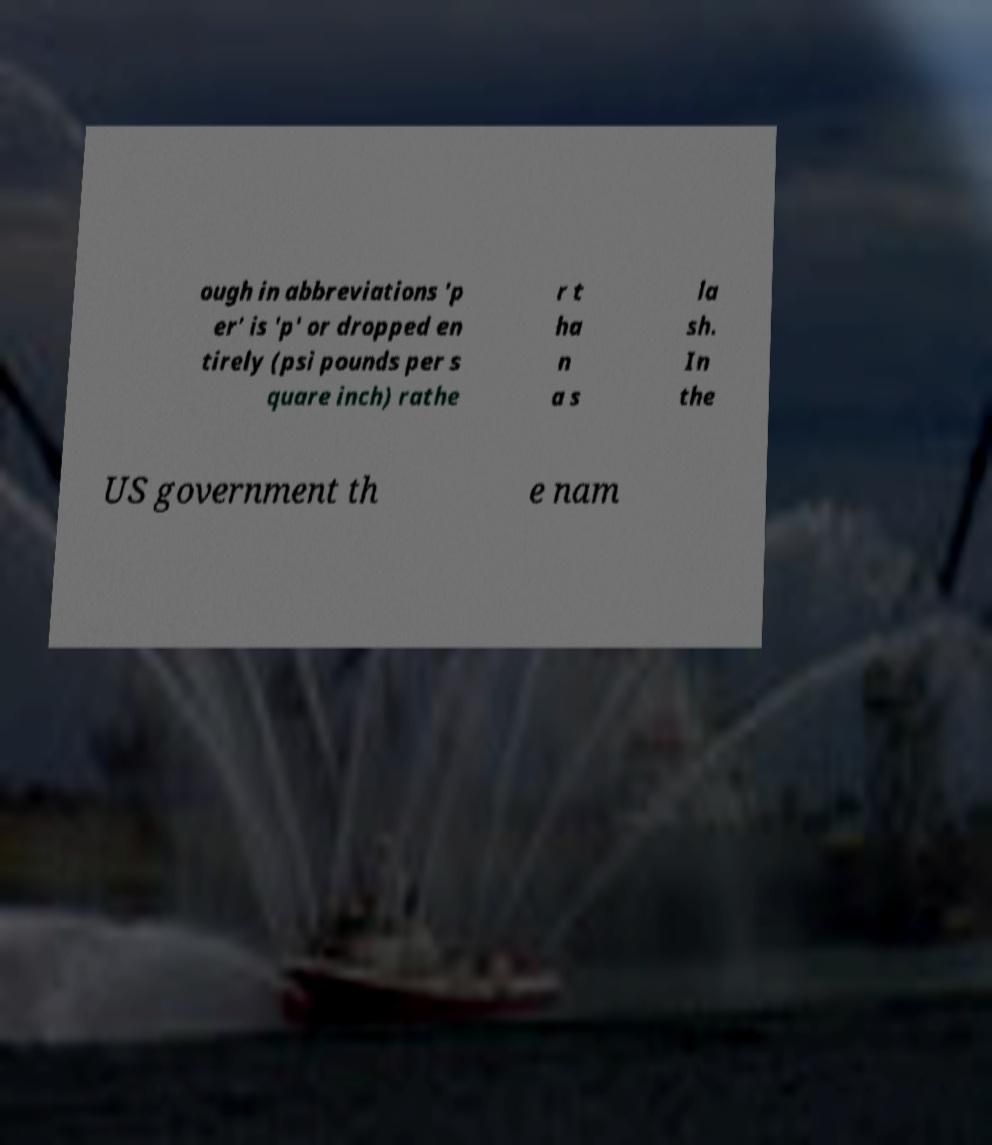Please identify and transcribe the text found in this image. ough in abbreviations 'p er' is 'p' or dropped en tirely (psi pounds per s quare inch) rathe r t ha n a s la sh. In the US government th e nam 